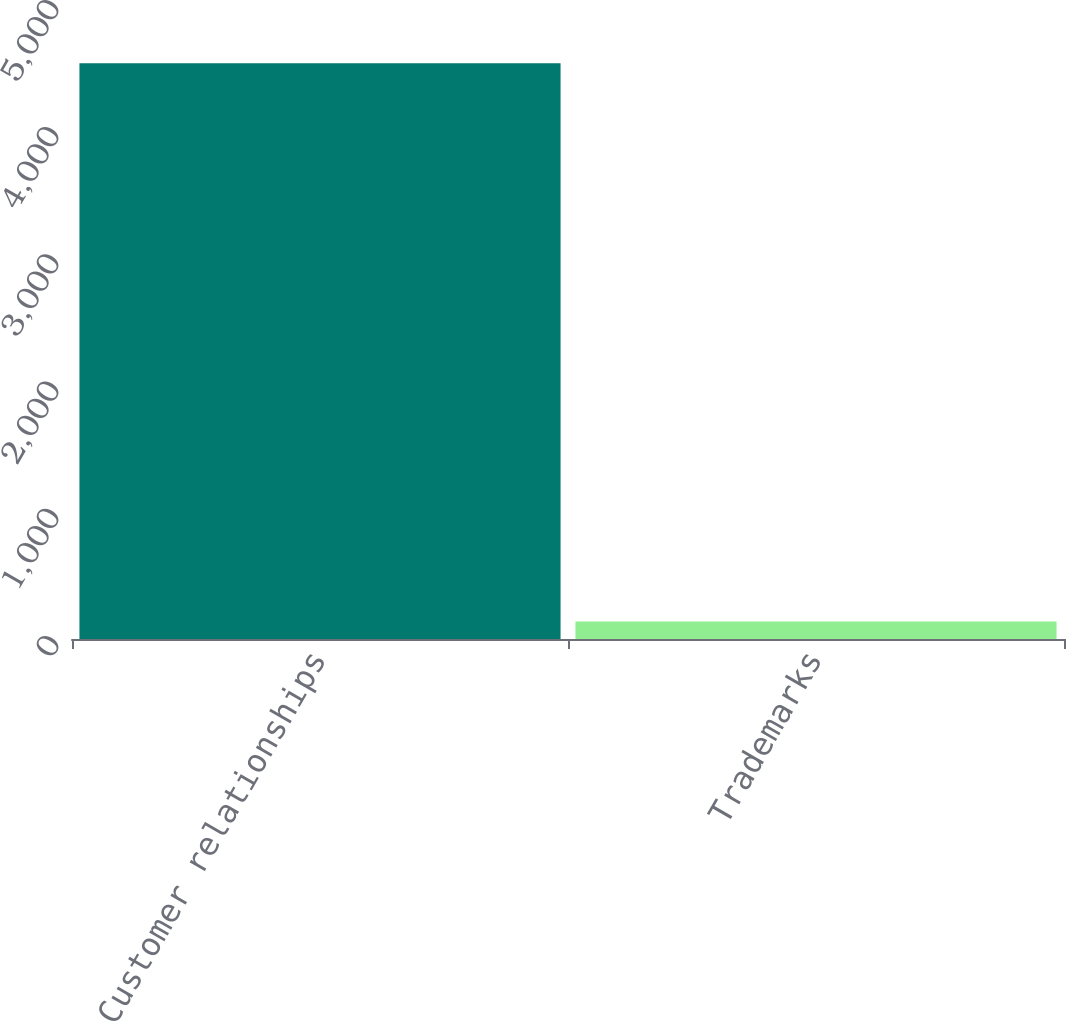Convert chart. <chart><loc_0><loc_0><loc_500><loc_500><bar_chart><fcel>Customer relationships<fcel>Trademarks<nl><fcel>4527<fcel>137<nl></chart> 